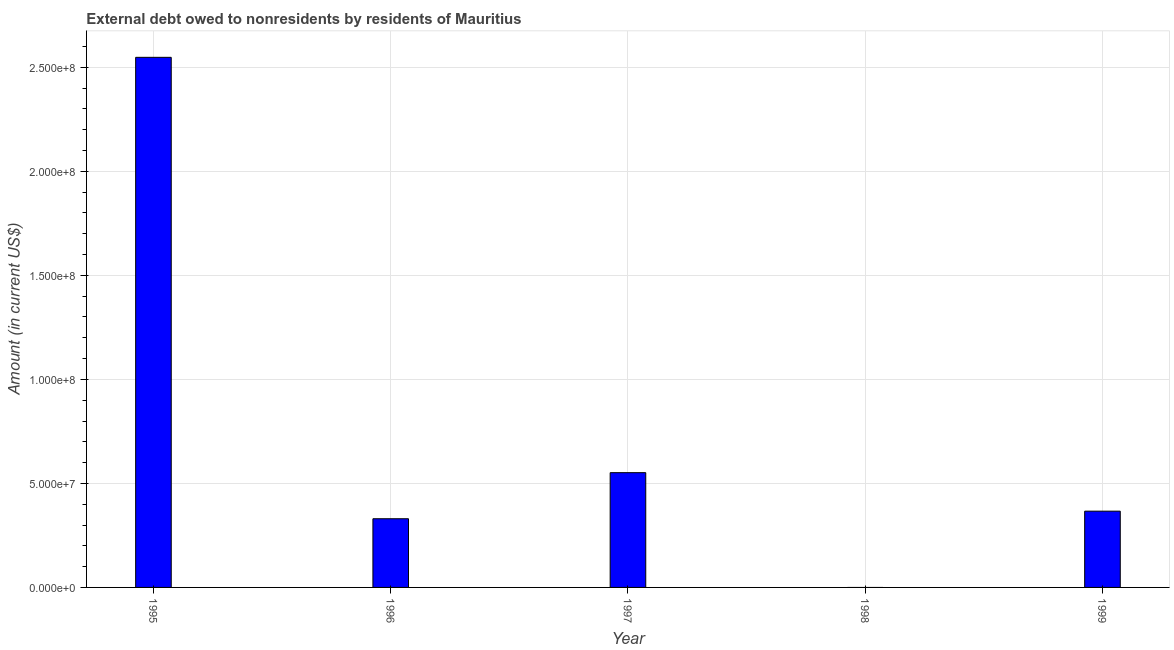Does the graph contain grids?
Your response must be concise. Yes. What is the title of the graph?
Offer a very short reply. External debt owed to nonresidents by residents of Mauritius. What is the debt in 1997?
Your response must be concise. 5.52e+07. Across all years, what is the maximum debt?
Give a very brief answer. 2.55e+08. Across all years, what is the minimum debt?
Keep it short and to the point. 0. What is the sum of the debt?
Make the answer very short. 3.80e+08. What is the difference between the debt in 1995 and 1996?
Offer a terse response. 2.22e+08. What is the average debt per year?
Your response must be concise. 7.59e+07. What is the median debt?
Offer a terse response. 3.67e+07. What is the ratio of the debt in 1995 to that in 1999?
Give a very brief answer. 6.95. Is the debt in 1996 less than that in 1999?
Your answer should be compact. Yes. Is the difference between the debt in 1996 and 1999 greater than the difference between any two years?
Offer a very short reply. No. What is the difference between the highest and the second highest debt?
Your answer should be compact. 2.00e+08. What is the difference between the highest and the lowest debt?
Your answer should be compact. 2.55e+08. Are all the bars in the graph horizontal?
Make the answer very short. No. How many years are there in the graph?
Make the answer very short. 5. What is the difference between two consecutive major ticks on the Y-axis?
Offer a very short reply. 5.00e+07. What is the Amount (in current US$) in 1995?
Your response must be concise. 2.55e+08. What is the Amount (in current US$) in 1996?
Provide a succinct answer. 3.30e+07. What is the Amount (in current US$) of 1997?
Offer a terse response. 5.52e+07. What is the Amount (in current US$) of 1999?
Make the answer very short. 3.67e+07. What is the difference between the Amount (in current US$) in 1995 and 1996?
Your answer should be compact. 2.22e+08. What is the difference between the Amount (in current US$) in 1995 and 1997?
Offer a very short reply. 2.00e+08. What is the difference between the Amount (in current US$) in 1995 and 1999?
Provide a short and direct response. 2.18e+08. What is the difference between the Amount (in current US$) in 1996 and 1997?
Your response must be concise. -2.21e+07. What is the difference between the Amount (in current US$) in 1996 and 1999?
Give a very brief answer. -3.64e+06. What is the difference between the Amount (in current US$) in 1997 and 1999?
Provide a short and direct response. 1.85e+07. What is the ratio of the Amount (in current US$) in 1995 to that in 1996?
Keep it short and to the point. 7.72. What is the ratio of the Amount (in current US$) in 1995 to that in 1997?
Ensure brevity in your answer.  4.62. What is the ratio of the Amount (in current US$) in 1995 to that in 1999?
Make the answer very short. 6.95. What is the ratio of the Amount (in current US$) in 1996 to that in 1997?
Your answer should be very brief. 0.6. What is the ratio of the Amount (in current US$) in 1996 to that in 1999?
Make the answer very short. 0.9. What is the ratio of the Amount (in current US$) in 1997 to that in 1999?
Ensure brevity in your answer.  1.5. 